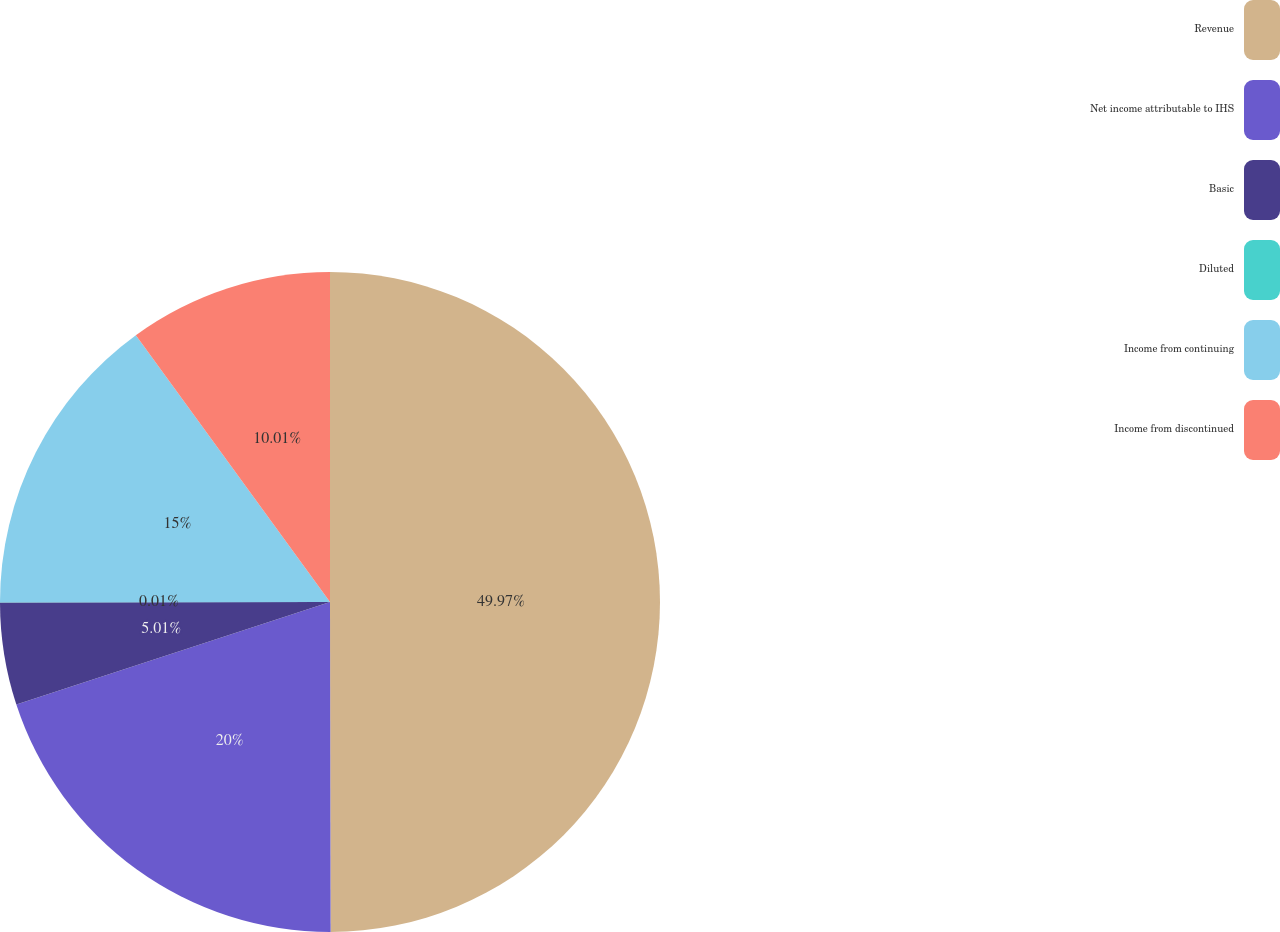Convert chart. <chart><loc_0><loc_0><loc_500><loc_500><pie_chart><fcel>Revenue<fcel>Net income attributable to IHS<fcel>Basic<fcel>Diluted<fcel>Income from continuing<fcel>Income from discontinued<nl><fcel>49.97%<fcel>20.0%<fcel>5.01%<fcel>0.01%<fcel>15.0%<fcel>10.01%<nl></chart> 